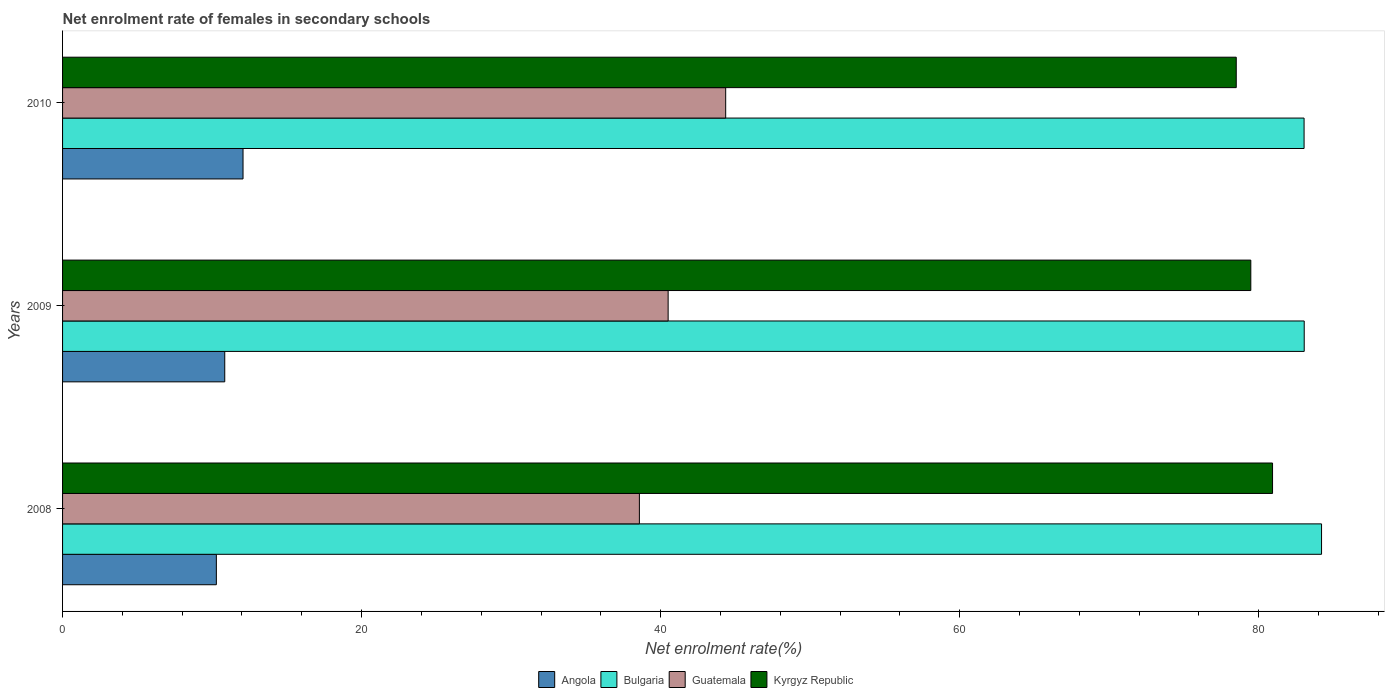How many different coloured bars are there?
Keep it short and to the point. 4. Are the number of bars on each tick of the Y-axis equal?
Offer a very short reply. Yes. How many bars are there on the 2nd tick from the bottom?
Make the answer very short. 4. What is the label of the 2nd group of bars from the top?
Make the answer very short. 2009. What is the net enrolment rate of females in secondary schools in Kyrgyz Republic in 2009?
Give a very brief answer. 79.48. Across all years, what is the maximum net enrolment rate of females in secondary schools in Kyrgyz Republic?
Ensure brevity in your answer.  80.93. Across all years, what is the minimum net enrolment rate of females in secondary schools in Bulgaria?
Make the answer very short. 83.04. In which year was the net enrolment rate of females in secondary schools in Kyrgyz Republic minimum?
Provide a short and direct response. 2010. What is the total net enrolment rate of females in secondary schools in Bulgaria in the graph?
Your answer should be very brief. 250.29. What is the difference between the net enrolment rate of females in secondary schools in Angola in 2008 and that in 2009?
Keep it short and to the point. -0.56. What is the difference between the net enrolment rate of females in secondary schools in Bulgaria in 2010 and the net enrolment rate of females in secondary schools in Guatemala in 2009?
Provide a short and direct response. 42.54. What is the average net enrolment rate of females in secondary schools in Bulgaria per year?
Keep it short and to the point. 83.43. In the year 2008, what is the difference between the net enrolment rate of females in secondary schools in Bulgaria and net enrolment rate of females in secondary schools in Kyrgyz Republic?
Offer a terse response. 3.28. In how many years, is the net enrolment rate of females in secondary schools in Kyrgyz Republic greater than 20 %?
Give a very brief answer. 3. What is the ratio of the net enrolment rate of females in secondary schools in Guatemala in 2009 to that in 2010?
Provide a short and direct response. 0.91. What is the difference between the highest and the second highest net enrolment rate of females in secondary schools in Guatemala?
Your answer should be very brief. 3.85. What is the difference between the highest and the lowest net enrolment rate of females in secondary schools in Kyrgyz Republic?
Provide a succinct answer. 2.43. In how many years, is the net enrolment rate of females in secondary schools in Angola greater than the average net enrolment rate of females in secondary schools in Angola taken over all years?
Provide a succinct answer. 1. What does the 2nd bar from the top in 2008 represents?
Provide a short and direct response. Guatemala. What does the 1st bar from the bottom in 2010 represents?
Offer a very short reply. Angola. Is it the case that in every year, the sum of the net enrolment rate of females in secondary schools in Angola and net enrolment rate of females in secondary schools in Bulgaria is greater than the net enrolment rate of females in secondary schools in Kyrgyz Republic?
Ensure brevity in your answer.  Yes. Are the values on the major ticks of X-axis written in scientific E-notation?
Ensure brevity in your answer.  No. Where does the legend appear in the graph?
Ensure brevity in your answer.  Bottom center. What is the title of the graph?
Offer a terse response. Net enrolment rate of females in secondary schools. Does "Sierra Leone" appear as one of the legend labels in the graph?
Provide a succinct answer. No. What is the label or title of the X-axis?
Offer a terse response. Net enrolment rate(%). What is the Net enrolment rate(%) in Angola in 2008?
Your response must be concise. 10.29. What is the Net enrolment rate(%) of Bulgaria in 2008?
Give a very brief answer. 84.21. What is the Net enrolment rate(%) in Guatemala in 2008?
Your response must be concise. 38.58. What is the Net enrolment rate(%) of Kyrgyz Republic in 2008?
Keep it short and to the point. 80.93. What is the Net enrolment rate(%) of Angola in 2009?
Your answer should be very brief. 10.85. What is the Net enrolment rate(%) of Bulgaria in 2009?
Keep it short and to the point. 83.05. What is the Net enrolment rate(%) of Guatemala in 2009?
Provide a succinct answer. 40.5. What is the Net enrolment rate(%) of Kyrgyz Republic in 2009?
Provide a succinct answer. 79.48. What is the Net enrolment rate(%) in Angola in 2010?
Your answer should be compact. 12.07. What is the Net enrolment rate(%) in Bulgaria in 2010?
Your response must be concise. 83.04. What is the Net enrolment rate(%) in Guatemala in 2010?
Your answer should be compact. 44.35. What is the Net enrolment rate(%) in Kyrgyz Republic in 2010?
Give a very brief answer. 78.5. Across all years, what is the maximum Net enrolment rate(%) of Angola?
Make the answer very short. 12.07. Across all years, what is the maximum Net enrolment rate(%) in Bulgaria?
Provide a short and direct response. 84.21. Across all years, what is the maximum Net enrolment rate(%) in Guatemala?
Offer a very short reply. 44.35. Across all years, what is the maximum Net enrolment rate(%) of Kyrgyz Republic?
Your answer should be compact. 80.93. Across all years, what is the minimum Net enrolment rate(%) of Angola?
Provide a succinct answer. 10.29. Across all years, what is the minimum Net enrolment rate(%) of Bulgaria?
Make the answer very short. 83.04. Across all years, what is the minimum Net enrolment rate(%) of Guatemala?
Make the answer very short. 38.58. Across all years, what is the minimum Net enrolment rate(%) of Kyrgyz Republic?
Provide a succinct answer. 78.5. What is the total Net enrolment rate(%) in Angola in the graph?
Offer a very short reply. 33.21. What is the total Net enrolment rate(%) in Bulgaria in the graph?
Make the answer very short. 250.29. What is the total Net enrolment rate(%) of Guatemala in the graph?
Provide a succinct answer. 123.44. What is the total Net enrolment rate(%) in Kyrgyz Republic in the graph?
Keep it short and to the point. 238.91. What is the difference between the Net enrolment rate(%) in Angola in 2008 and that in 2009?
Your response must be concise. -0.56. What is the difference between the Net enrolment rate(%) of Bulgaria in 2008 and that in 2009?
Keep it short and to the point. 1.16. What is the difference between the Net enrolment rate(%) in Guatemala in 2008 and that in 2009?
Keep it short and to the point. -1.92. What is the difference between the Net enrolment rate(%) in Kyrgyz Republic in 2008 and that in 2009?
Offer a very short reply. 1.45. What is the difference between the Net enrolment rate(%) in Angola in 2008 and that in 2010?
Offer a very short reply. -1.78. What is the difference between the Net enrolment rate(%) of Bulgaria in 2008 and that in 2010?
Your answer should be very brief. 1.17. What is the difference between the Net enrolment rate(%) in Guatemala in 2008 and that in 2010?
Your answer should be very brief. -5.77. What is the difference between the Net enrolment rate(%) in Kyrgyz Republic in 2008 and that in 2010?
Keep it short and to the point. 2.43. What is the difference between the Net enrolment rate(%) in Angola in 2009 and that in 2010?
Give a very brief answer. -1.22. What is the difference between the Net enrolment rate(%) of Bulgaria in 2009 and that in 2010?
Offer a terse response. 0.01. What is the difference between the Net enrolment rate(%) of Guatemala in 2009 and that in 2010?
Make the answer very short. -3.85. What is the difference between the Net enrolment rate(%) of Kyrgyz Republic in 2009 and that in 2010?
Provide a succinct answer. 0.97. What is the difference between the Net enrolment rate(%) of Angola in 2008 and the Net enrolment rate(%) of Bulgaria in 2009?
Your answer should be compact. -72.76. What is the difference between the Net enrolment rate(%) of Angola in 2008 and the Net enrolment rate(%) of Guatemala in 2009?
Your answer should be very brief. -30.22. What is the difference between the Net enrolment rate(%) in Angola in 2008 and the Net enrolment rate(%) in Kyrgyz Republic in 2009?
Your answer should be very brief. -69.19. What is the difference between the Net enrolment rate(%) of Bulgaria in 2008 and the Net enrolment rate(%) of Guatemala in 2009?
Offer a very short reply. 43.7. What is the difference between the Net enrolment rate(%) of Bulgaria in 2008 and the Net enrolment rate(%) of Kyrgyz Republic in 2009?
Make the answer very short. 4.73. What is the difference between the Net enrolment rate(%) of Guatemala in 2008 and the Net enrolment rate(%) of Kyrgyz Republic in 2009?
Ensure brevity in your answer.  -40.9. What is the difference between the Net enrolment rate(%) of Angola in 2008 and the Net enrolment rate(%) of Bulgaria in 2010?
Keep it short and to the point. -72.75. What is the difference between the Net enrolment rate(%) of Angola in 2008 and the Net enrolment rate(%) of Guatemala in 2010?
Offer a terse response. -34.07. What is the difference between the Net enrolment rate(%) in Angola in 2008 and the Net enrolment rate(%) in Kyrgyz Republic in 2010?
Your answer should be very brief. -68.22. What is the difference between the Net enrolment rate(%) in Bulgaria in 2008 and the Net enrolment rate(%) in Guatemala in 2010?
Offer a terse response. 39.85. What is the difference between the Net enrolment rate(%) in Bulgaria in 2008 and the Net enrolment rate(%) in Kyrgyz Republic in 2010?
Your answer should be compact. 5.71. What is the difference between the Net enrolment rate(%) of Guatemala in 2008 and the Net enrolment rate(%) of Kyrgyz Republic in 2010?
Give a very brief answer. -39.92. What is the difference between the Net enrolment rate(%) of Angola in 2009 and the Net enrolment rate(%) of Bulgaria in 2010?
Your response must be concise. -72.19. What is the difference between the Net enrolment rate(%) of Angola in 2009 and the Net enrolment rate(%) of Guatemala in 2010?
Offer a terse response. -33.5. What is the difference between the Net enrolment rate(%) of Angola in 2009 and the Net enrolment rate(%) of Kyrgyz Republic in 2010?
Your answer should be compact. -67.65. What is the difference between the Net enrolment rate(%) in Bulgaria in 2009 and the Net enrolment rate(%) in Guatemala in 2010?
Your answer should be very brief. 38.7. What is the difference between the Net enrolment rate(%) of Bulgaria in 2009 and the Net enrolment rate(%) of Kyrgyz Republic in 2010?
Offer a terse response. 4.55. What is the difference between the Net enrolment rate(%) of Guatemala in 2009 and the Net enrolment rate(%) of Kyrgyz Republic in 2010?
Your response must be concise. -38. What is the average Net enrolment rate(%) in Angola per year?
Your response must be concise. 11.07. What is the average Net enrolment rate(%) of Bulgaria per year?
Your answer should be compact. 83.43. What is the average Net enrolment rate(%) in Guatemala per year?
Keep it short and to the point. 41.15. What is the average Net enrolment rate(%) of Kyrgyz Republic per year?
Your response must be concise. 79.64. In the year 2008, what is the difference between the Net enrolment rate(%) of Angola and Net enrolment rate(%) of Bulgaria?
Ensure brevity in your answer.  -73.92. In the year 2008, what is the difference between the Net enrolment rate(%) in Angola and Net enrolment rate(%) in Guatemala?
Offer a terse response. -28.29. In the year 2008, what is the difference between the Net enrolment rate(%) of Angola and Net enrolment rate(%) of Kyrgyz Republic?
Your answer should be compact. -70.64. In the year 2008, what is the difference between the Net enrolment rate(%) in Bulgaria and Net enrolment rate(%) in Guatemala?
Keep it short and to the point. 45.63. In the year 2008, what is the difference between the Net enrolment rate(%) in Bulgaria and Net enrolment rate(%) in Kyrgyz Republic?
Your answer should be very brief. 3.28. In the year 2008, what is the difference between the Net enrolment rate(%) in Guatemala and Net enrolment rate(%) in Kyrgyz Republic?
Make the answer very short. -42.35. In the year 2009, what is the difference between the Net enrolment rate(%) in Angola and Net enrolment rate(%) in Bulgaria?
Your answer should be very brief. -72.2. In the year 2009, what is the difference between the Net enrolment rate(%) of Angola and Net enrolment rate(%) of Guatemala?
Keep it short and to the point. -29.66. In the year 2009, what is the difference between the Net enrolment rate(%) in Angola and Net enrolment rate(%) in Kyrgyz Republic?
Your answer should be compact. -68.63. In the year 2009, what is the difference between the Net enrolment rate(%) in Bulgaria and Net enrolment rate(%) in Guatemala?
Provide a succinct answer. 42.54. In the year 2009, what is the difference between the Net enrolment rate(%) of Bulgaria and Net enrolment rate(%) of Kyrgyz Republic?
Offer a terse response. 3.57. In the year 2009, what is the difference between the Net enrolment rate(%) of Guatemala and Net enrolment rate(%) of Kyrgyz Republic?
Your response must be concise. -38.97. In the year 2010, what is the difference between the Net enrolment rate(%) of Angola and Net enrolment rate(%) of Bulgaria?
Provide a succinct answer. -70.97. In the year 2010, what is the difference between the Net enrolment rate(%) of Angola and Net enrolment rate(%) of Guatemala?
Offer a very short reply. -32.28. In the year 2010, what is the difference between the Net enrolment rate(%) of Angola and Net enrolment rate(%) of Kyrgyz Republic?
Provide a succinct answer. -66.43. In the year 2010, what is the difference between the Net enrolment rate(%) of Bulgaria and Net enrolment rate(%) of Guatemala?
Provide a short and direct response. 38.69. In the year 2010, what is the difference between the Net enrolment rate(%) in Bulgaria and Net enrolment rate(%) in Kyrgyz Republic?
Give a very brief answer. 4.54. In the year 2010, what is the difference between the Net enrolment rate(%) of Guatemala and Net enrolment rate(%) of Kyrgyz Republic?
Make the answer very short. -34.15. What is the ratio of the Net enrolment rate(%) in Angola in 2008 to that in 2009?
Your response must be concise. 0.95. What is the ratio of the Net enrolment rate(%) in Bulgaria in 2008 to that in 2009?
Provide a short and direct response. 1.01. What is the ratio of the Net enrolment rate(%) in Guatemala in 2008 to that in 2009?
Your response must be concise. 0.95. What is the ratio of the Net enrolment rate(%) of Kyrgyz Republic in 2008 to that in 2009?
Your answer should be compact. 1.02. What is the ratio of the Net enrolment rate(%) in Angola in 2008 to that in 2010?
Your answer should be compact. 0.85. What is the ratio of the Net enrolment rate(%) in Bulgaria in 2008 to that in 2010?
Keep it short and to the point. 1.01. What is the ratio of the Net enrolment rate(%) of Guatemala in 2008 to that in 2010?
Your response must be concise. 0.87. What is the ratio of the Net enrolment rate(%) in Kyrgyz Republic in 2008 to that in 2010?
Your response must be concise. 1.03. What is the ratio of the Net enrolment rate(%) of Angola in 2009 to that in 2010?
Provide a succinct answer. 0.9. What is the ratio of the Net enrolment rate(%) in Bulgaria in 2009 to that in 2010?
Give a very brief answer. 1. What is the ratio of the Net enrolment rate(%) in Guatemala in 2009 to that in 2010?
Provide a succinct answer. 0.91. What is the ratio of the Net enrolment rate(%) of Kyrgyz Republic in 2009 to that in 2010?
Offer a terse response. 1.01. What is the difference between the highest and the second highest Net enrolment rate(%) of Angola?
Offer a very short reply. 1.22. What is the difference between the highest and the second highest Net enrolment rate(%) in Bulgaria?
Your answer should be compact. 1.16. What is the difference between the highest and the second highest Net enrolment rate(%) of Guatemala?
Your answer should be very brief. 3.85. What is the difference between the highest and the second highest Net enrolment rate(%) of Kyrgyz Republic?
Make the answer very short. 1.45. What is the difference between the highest and the lowest Net enrolment rate(%) in Angola?
Provide a short and direct response. 1.78. What is the difference between the highest and the lowest Net enrolment rate(%) of Bulgaria?
Ensure brevity in your answer.  1.17. What is the difference between the highest and the lowest Net enrolment rate(%) in Guatemala?
Provide a short and direct response. 5.77. What is the difference between the highest and the lowest Net enrolment rate(%) in Kyrgyz Republic?
Give a very brief answer. 2.43. 